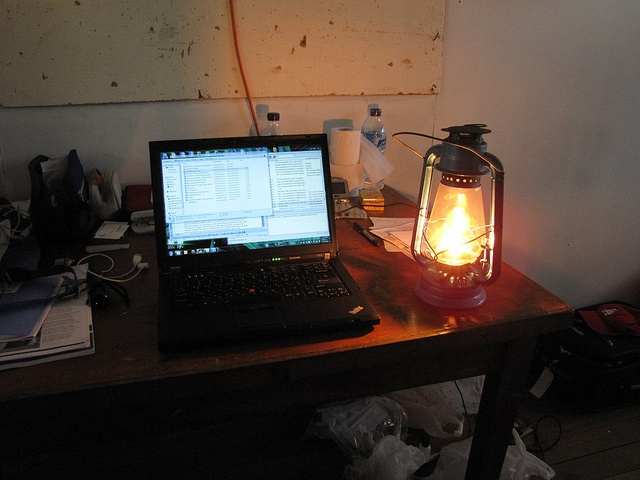Describe the objects in this image and their specific colors. I can see laptop in gray, black, lightblue, and maroon tones, keyboard in gray, black, and maroon tones, book in gray and black tones, bottle in gray and black tones, and bottle in gray, maroon, and black tones in this image. 